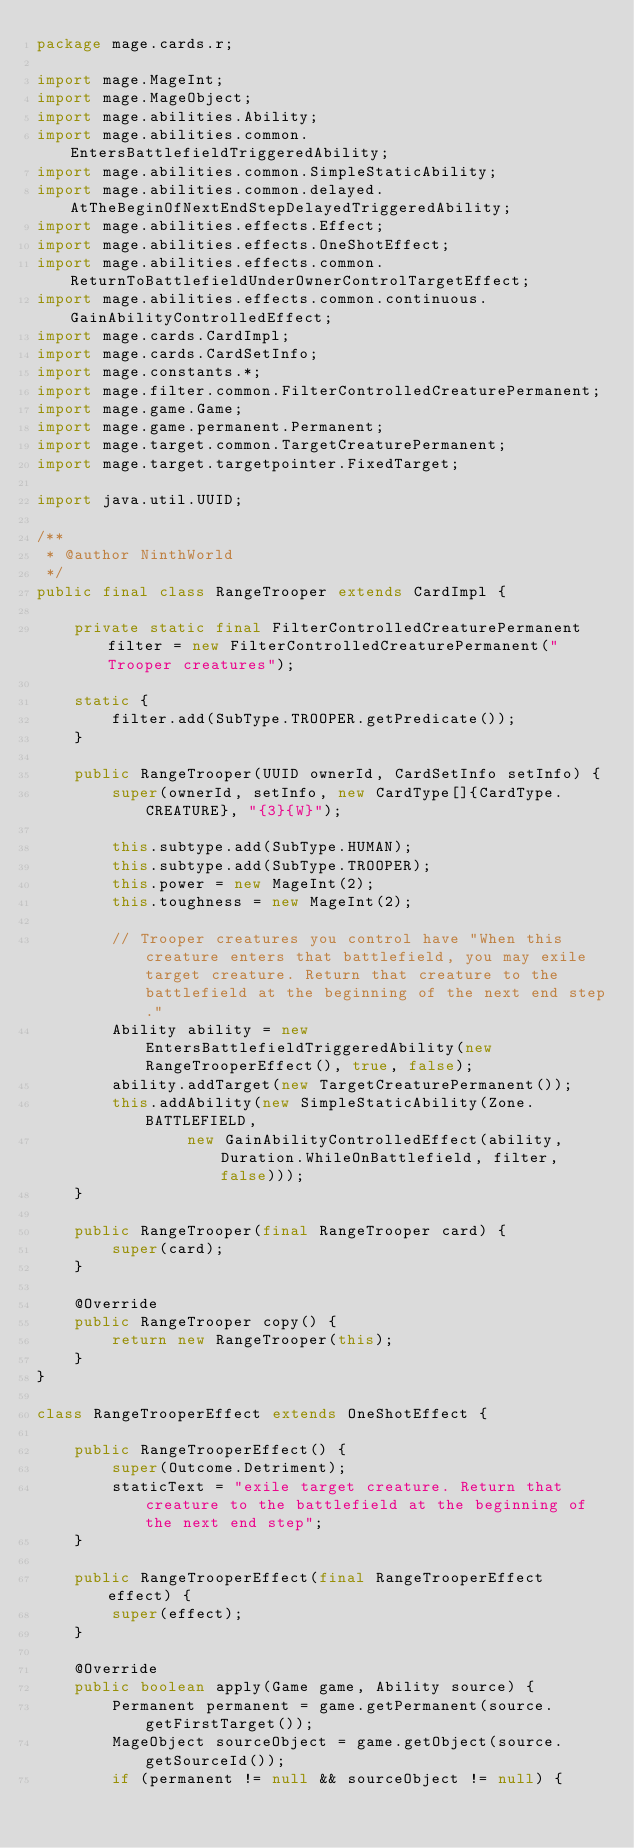Convert code to text. <code><loc_0><loc_0><loc_500><loc_500><_Java_>package mage.cards.r;

import mage.MageInt;
import mage.MageObject;
import mage.abilities.Ability;
import mage.abilities.common.EntersBattlefieldTriggeredAbility;
import mage.abilities.common.SimpleStaticAbility;
import mage.abilities.common.delayed.AtTheBeginOfNextEndStepDelayedTriggeredAbility;
import mage.abilities.effects.Effect;
import mage.abilities.effects.OneShotEffect;
import mage.abilities.effects.common.ReturnToBattlefieldUnderOwnerControlTargetEffect;
import mage.abilities.effects.common.continuous.GainAbilityControlledEffect;
import mage.cards.CardImpl;
import mage.cards.CardSetInfo;
import mage.constants.*;
import mage.filter.common.FilterControlledCreaturePermanent;
import mage.game.Game;
import mage.game.permanent.Permanent;
import mage.target.common.TargetCreaturePermanent;
import mage.target.targetpointer.FixedTarget;

import java.util.UUID;

/**
 * @author NinthWorld
 */
public final class RangeTrooper extends CardImpl {

    private static final FilterControlledCreaturePermanent filter = new FilterControlledCreaturePermanent("Trooper creatures");

    static {
        filter.add(SubType.TROOPER.getPredicate());
    }

    public RangeTrooper(UUID ownerId, CardSetInfo setInfo) {
        super(ownerId, setInfo, new CardType[]{CardType.CREATURE}, "{3}{W}");

        this.subtype.add(SubType.HUMAN);
        this.subtype.add(SubType.TROOPER);
        this.power = new MageInt(2);
        this.toughness = new MageInt(2);

        // Trooper creatures you control have "When this creature enters that battlefield, you may exile target creature. Return that creature to the battlefield at the beginning of the next end step."
        Ability ability = new EntersBattlefieldTriggeredAbility(new RangeTrooperEffect(), true, false);
        ability.addTarget(new TargetCreaturePermanent());
        this.addAbility(new SimpleStaticAbility(Zone.BATTLEFIELD,
                new GainAbilityControlledEffect(ability, Duration.WhileOnBattlefield, filter, false)));
    }

    public RangeTrooper(final RangeTrooper card) {
        super(card);
    }

    @Override
    public RangeTrooper copy() {
        return new RangeTrooper(this);
    }
}

class RangeTrooperEffect extends OneShotEffect {

    public RangeTrooperEffect() {
        super(Outcome.Detriment);
        staticText = "exile target creature. Return that creature to the battlefield at the beginning of the next end step";
    }

    public RangeTrooperEffect(final RangeTrooperEffect effect) {
        super(effect);
    }

    @Override
    public boolean apply(Game game, Ability source) {
        Permanent permanent = game.getPermanent(source.getFirstTarget());
        MageObject sourceObject = game.getObject(source.getSourceId());
        if (permanent != null && sourceObject != null) {</code> 